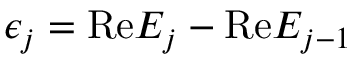Convert formula to latex. <formula><loc_0><loc_0><loc_500><loc_500>\epsilon _ { j } = R e E _ { j } - R e E _ { j - 1 }</formula> 